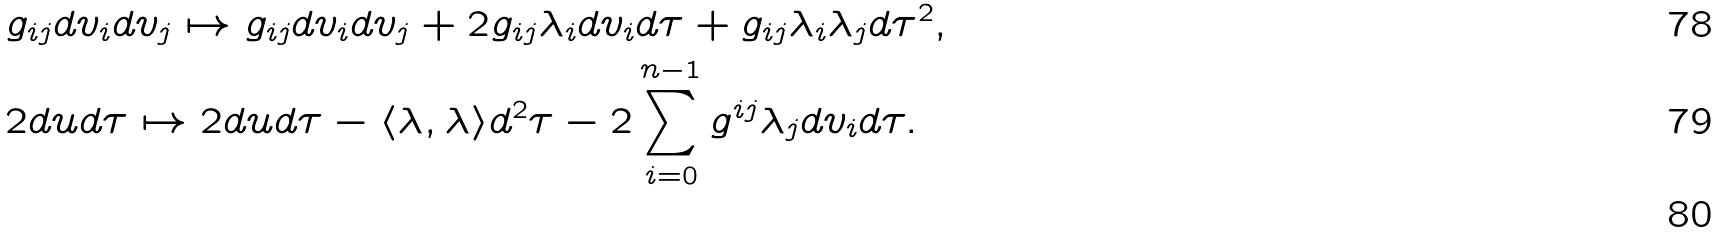<formula> <loc_0><loc_0><loc_500><loc_500>& g _ { i j } d v _ { i } d v _ { j } \mapsto g _ { i j } d v _ { i } d v _ { j } + 2 g _ { i j } \lambda _ { i } d v _ { i } d \tau + g _ { i j } \lambda _ { i } \lambda _ { j } d \tau ^ { 2 } , \\ & 2 d u d \tau \mapsto 2 d u d \tau - \langle \lambda , \lambda \rangle d ^ { 2 } \tau - 2 \sum _ { i = 0 } ^ { n - 1 } g ^ { i j } \lambda _ { j } d v _ { i } d \tau . \\</formula> 